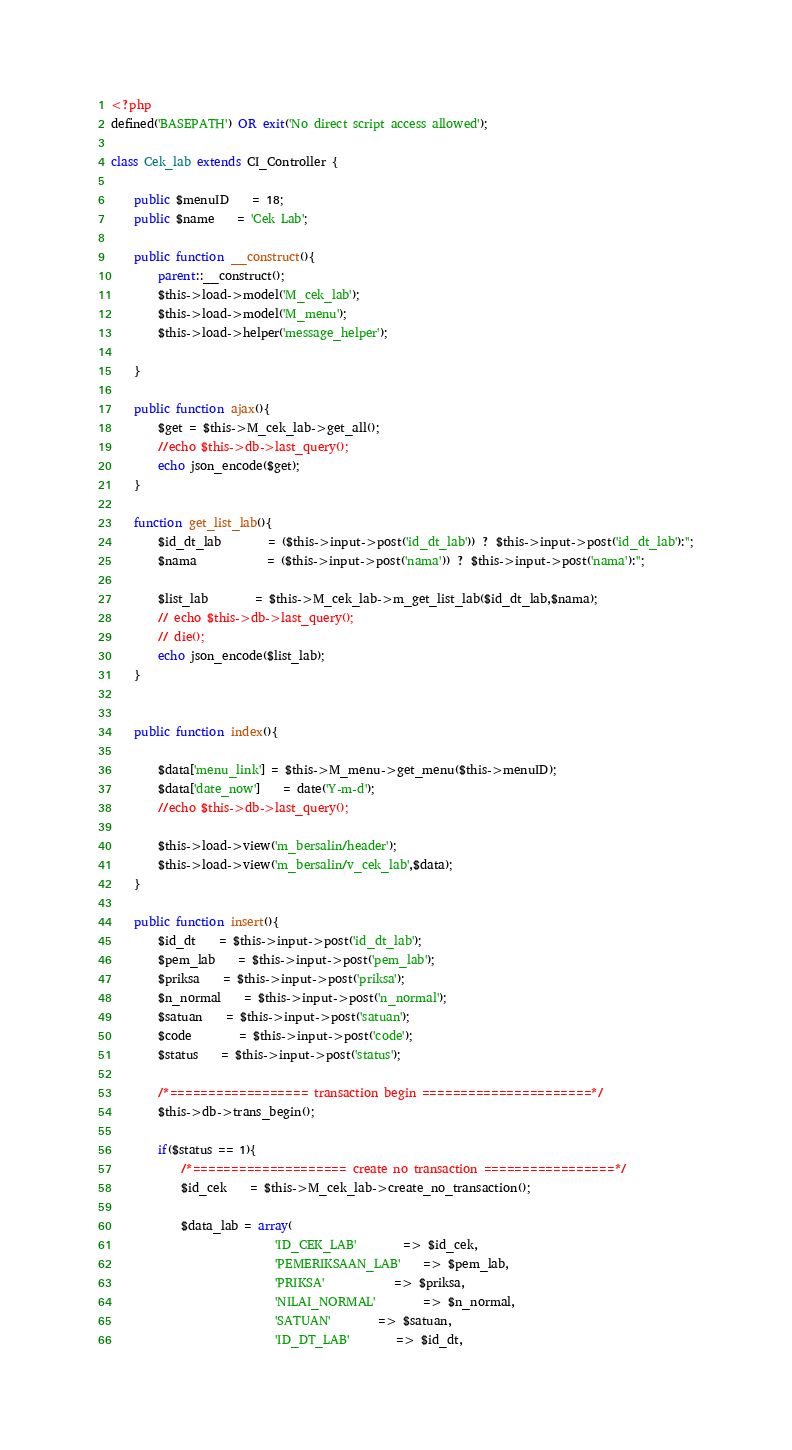<code> <loc_0><loc_0><loc_500><loc_500><_PHP_><?php
defined('BASEPATH') OR exit('No direct script access allowed');

class Cek_lab extends CI_Controller {

	public $menuID 	= 18;
	public $name 	= 'Cek Lab';

	public function __construct(){
        parent::__construct();
		$this->load->model('M_cek_lab');
		$this->load->model('M_menu');
		$this->load->helper('message_helper');
		
	}

	public function ajax(){
		$get = $this->M_cek_lab->get_all();
		//echo $this->db->last_query();
		echo json_encode($get);
	}
	
	function get_list_lab(){
		$id_dt_lab 		= ($this->input->post('id_dt_lab')) ? $this->input->post('id_dt_lab'):'';
		$nama    		= ($this->input->post('nama')) ? $this->input->post('nama'):'';

		$list_lab 		= $this->M_cek_lab->m_get_list_lab($id_dt_lab,$nama);
		// echo $this->db->last_query();
		// die();
		echo json_encode($list_lab);
	}
	

	public function index(){

		$data['menu_link'] = $this->M_menu->get_menu($this->menuID);
		$data['date_now'] 	= date('Y-m-d');
		//echo $this->db->last_query();

		$this->load->view('m_bersalin/header');
		$this->load->view('m_bersalin/v_cek_lab',$data);
	}

	public function insert(){
		$id_dt 	= $this->input->post('id_dt_lab');
		$pem_lab   	= $this->input->post('pem_lab');
	    $priksa 	= $this->input->post('priksa');
		$n_normal   	= $this->input->post('n_normal');
		$satuan   	= $this->input->post('satuan');
		$code 		= $this->input->post('code');
		$status 	= $this->input->post('status');

		/*================== transaction begin ======================*/
		$this->db->trans_begin();

		if($status == 1){
			/*==================== create no transaction =================*/
			$id_cek 	= $this->M_cek_lab->create_no_transaction();

			$data_lab = array(
							'ID_CEK_LAB'  		=> $id_cek,
							'PEMERIKSAAN_LAB'	=> $pem_lab,
							'PRIKSA' 			=> $priksa,
							'NILAI_NORMAL'		=> $n_normal,
							'SATUAN' 		=> $satuan,
							'ID_DT_LAB' 		=> $id_dt,</code> 